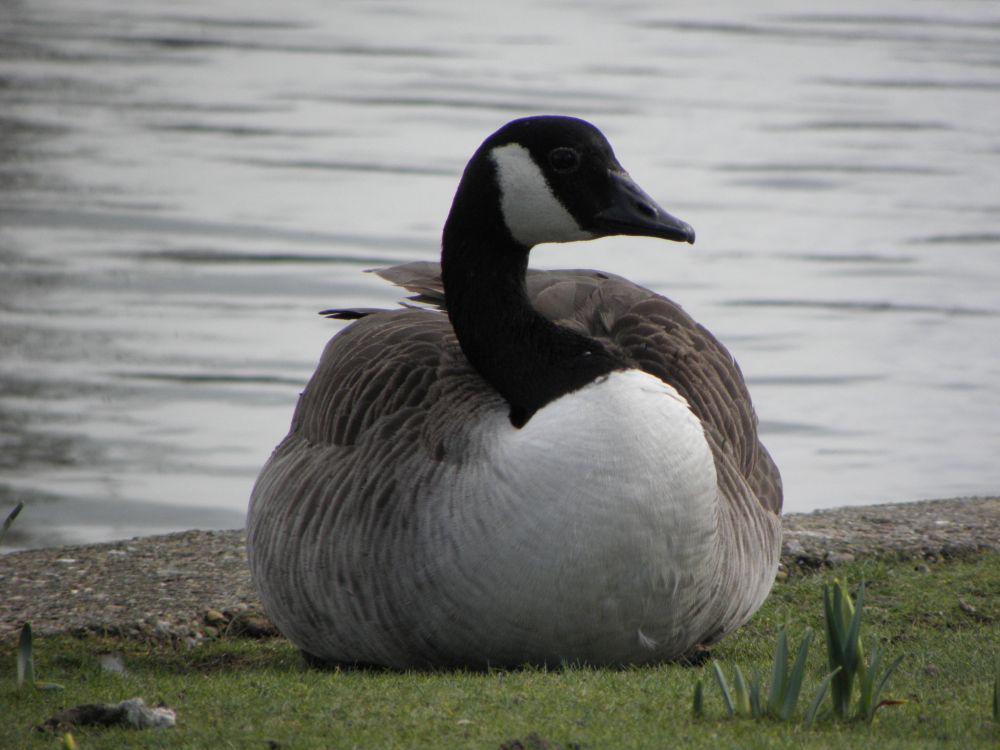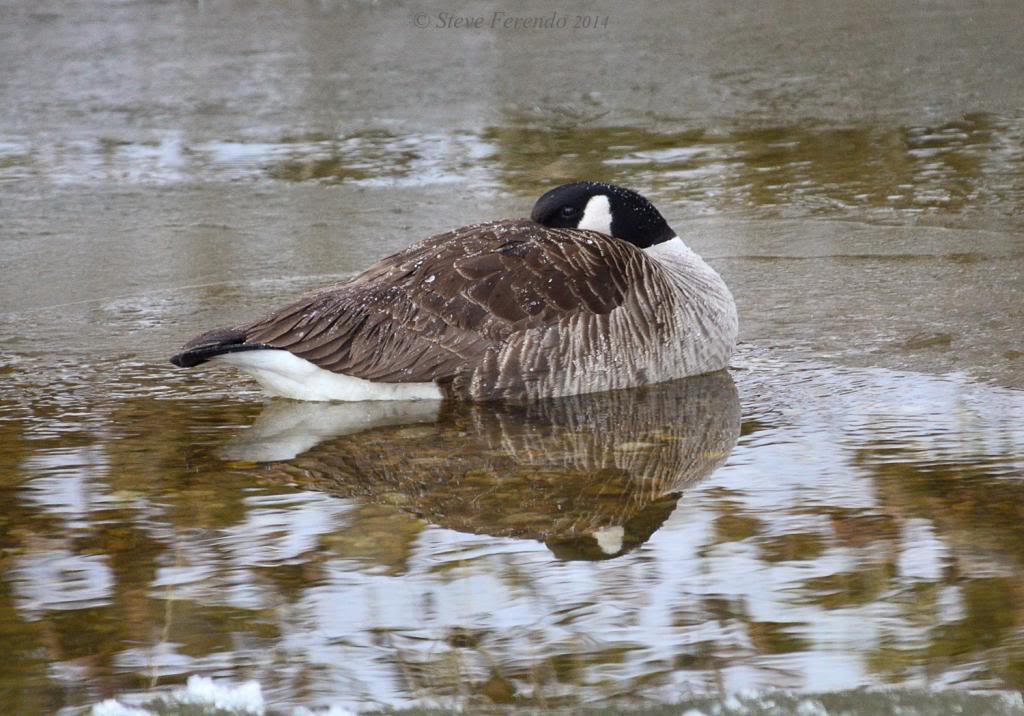The first image is the image on the left, the second image is the image on the right. Assess this claim about the two images: "An image shows one bird in the water, with its neck turned backward.". Correct or not? Answer yes or no. Yes. 